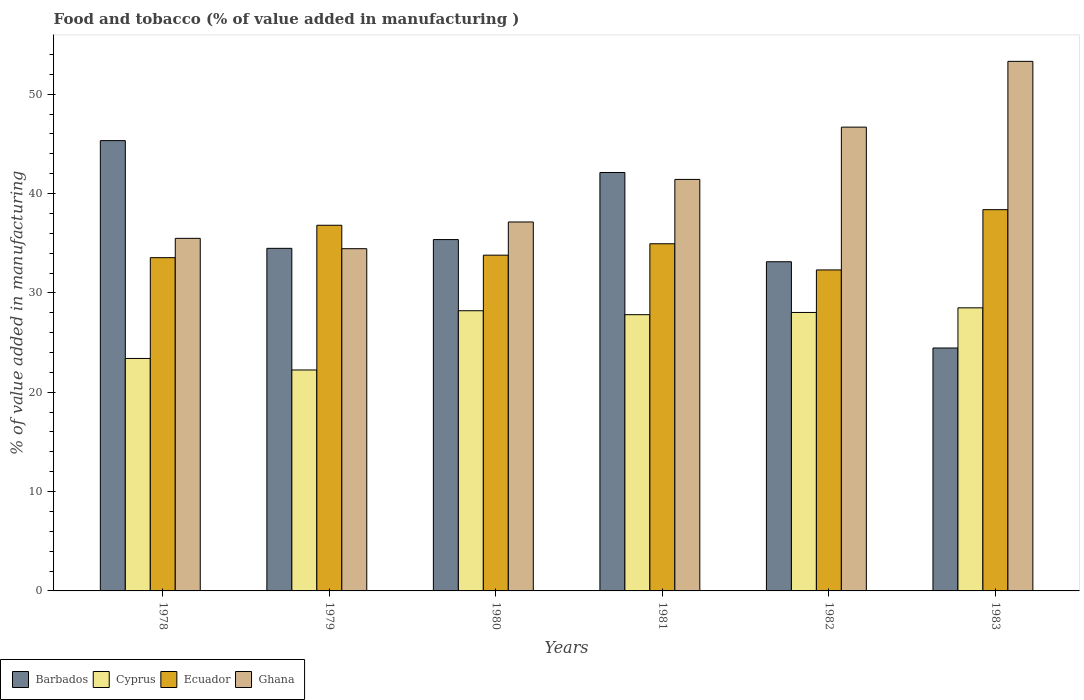How many different coloured bars are there?
Offer a very short reply. 4. Are the number of bars per tick equal to the number of legend labels?
Your answer should be very brief. Yes. Are the number of bars on each tick of the X-axis equal?
Give a very brief answer. Yes. How many bars are there on the 1st tick from the right?
Ensure brevity in your answer.  4. What is the label of the 5th group of bars from the left?
Your answer should be very brief. 1982. In how many cases, is the number of bars for a given year not equal to the number of legend labels?
Your answer should be compact. 0. What is the value added in manufacturing food and tobacco in Barbados in 1981?
Your answer should be compact. 42.12. Across all years, what is the maximum value added in manufacturing food and tobacco in Ecuador?
Make the answer very short. 38.38. Across all years, what is the minimum value added in manufacturing food and tobacco in Ghana?
Provide a succinct answer. 34.45. In which year was the value added in manufacturing food and tobacco in Ghana minimum?
Your answer should be compact. 1979. What is the total value added in manufacturing food and tobacco in Ecuador in the graph?
Make the answer very short. 209.78. What is the difference between the value added in manufacturing food and tobacco in Ghana in 1981 and that in 1983?
Offer a terse response. -11.88. What is the difference between the value added in manufacturing food and tobacco in Ghana in 1981 and the value added in manufacturing food and tobacco in Barbados in 1982?
Offer a very short reply. 8.29. What is the average value added in manufacturing food and tobacco in Ghana per year?
Keep it short and to the point. 41.41. In the year 1980, what is the difference between the value added in manufacturing food and tobacco in Cyprus and value added in manufacturing food and tobacco in Ghana?
Ensure brevity in your answer.  -8.93. In how many years, is the value added in manufacturing food and tobacco in Ghana greater than 16 %?
Ensure brevity in your answer.  6. What is the ratio of the value added in manufacturing food and tobacco in Barbados in 1979 to that in 1983?
Ensure brevity in your answer.  1.41. What is the difference between the highest and the second highest value added in manufacturing food and tobacco in Cyprus?
Ensure brevity in your answer.  0.29. What is the difference between the highest and the lowest value added in manufacturing food and tobacco in Ghana?
Provide a succinct answer. 18.86. Is the sum of the value added in manufacturing food and tobacco in Ecuador in 1979 and 1981 greater than the maximum value added in manufacturing food and tobacco in Cyprus across all years?
Your answer should be compact. Yes. What does the 2nd bar from the left in 1978 represents?
Provide a short and direct response. Cyprus. What does the 4th bar from the right in 1983 represents?
Make the answer very short. Barbados. Is it the case that in every year, the sum of the value added in manufacturing food and tobacco in Ghana and value added in manufacturing food and tobacco in Barbados is greater than the value added in manufacturing food and tobacco in Ecuador?
Offer a very short reply. Yes. Are all the bars in the graph horizontal?
Give a very brief answer. No. What is the difference between two consecutive major ticks on the Y-axis?
Your answer should be compact. 10. Where does the legend appear in the graph?
Provide a short and direct response. Bottom left. What is the title of the graph?
Offer a terse response. Food and tobacco (% of value added in manufacturing ). Does "Andorra" appear as one of the legend labels in the graph?
Your response must be concise. No. What is the label or title of the Y-axis?
Provide a succinct answer. % of value added in manufacturing. What is the % of value added in manufacturing of Barbados in 1978?
Give a very brief answer. 45.33. What is the % of value added in manufacturing in Cyprus in 1978?
Your answer should be compact. 23.4. What is the % of value added in manufacturing in Ecuador in 1978?
Your answer should be very brief. 33.54. What is the % of value added in manufacturing in Ghana in 1978?
Provide a short and direct response. 35.49. What is the % of value added in manufacturing of Barbados in 1979?
Ensure brevity in your answer.  34.48. What is the % of value added in manufacturing in Cyprus in 1979?
Keep it short and to the point. 22.24. What is the % of value added in manufacturing of Ecuador in 1979?
Give a very brief answer. 36.81. What is the % of value added in manufacturing in Ghana in 1979?
Give a very brief answer. 34.45. What is the % of value added in manufacturing of Barbados in 1980?
Keep it short and to the point. 35.37. What is the % of value added in manufacturing in Cyprus in 1980?
Keep it short and to the point. 28.2. What is the % of value added in manufacturing of Ecuador in 1980?
Keep it short and to the point. 33.8. What is the % of value added in manufacturing of Ghana in 1980?
Make the answer very short. 37.14. What is the % of value added in manufacturing in Barbados in 1981?
Your answer should be compact. 42.12. What is the % of value added in manufacturing in Cyprus in 1981?
Make the answer very short. 27.81. What is the % of value added in manufacturing of Ecuador in 1981?
Ensure brevity in your answer.  34.94. What is the % of value added in manufacturing in Ghana in 1981?
Offer a very short reply. 41.42. What is the % of value added in manufacturing in Barbados in 1982?
Offer a terse response. 33.13. What is the % of value added in manufacturing in Cyprus in 1982?
Your answer should be very brief. 28.03. What is the % of value added in manufacturing in Ecuador in 1982?
Offer a terse response. 32.31. What is the % of value added in manufacturing of Ghana in 1982?
Make the answer very short. 46.68. What is the % of value added in manufacturing in Barbados in 1983?
Offer a terse response. 24.45. What is the % of value added in manufacturing in Cyprus in 1983?
Keep it short and to the point. 28.49. What is the % of value added in manufacturing of Ecuador in 1983?
Your answer should be very brief. 38.38. What is the % of value added in manufacturing of Ghana in 1983?
Your answer should be very brief. 53.3. Across all years, what is the maximum % of value added in manufacturing of Barbados?
Offer a terse response. 45.33. Across all years, what is the maximum % of value added in manufacturing in Cyprus?
Ensure brevity in your answer.  28.49. Across all years, what is the maximum % of value added in manufacturing in Ecuador?
Your response must be concise. 38.38. Across all years, what is the maximum % of value added in manufacturing in Ghana?
Offer a terse response. 53.3. Across all years, what is the minimum % of value added in manufacturing in Barbados?
Offer a very short reply. 24.45. Across all years, what is the minimum % of value added in manufacturing of Cyprus?
Keep it short and to the point. 22.24. Across all years, what is the minimum % of value added in manufacturing in Ecuador?
Provide a short and direct response. 32.31. Across all years, what is the minimum % of value added in manufacturing of Ghana?
Offer a very short reply. 34.45. What is the total % of value added in manufacturing in Barbados in the graph?
Make the answer very short. 214.88. What is the total % of value added in manufacturing in Cyprus in the graph?
Offer a very short reply. 158.17. What is the total % of value added in manufacturing of Ecuador in the graph?
Make the answer very short. 209.78. What is the total % of value added in manufacturing in Ghana in the graph?
Make the answer very short. 248.48. What is the difference between the % of value added in manufacturing of Barbados in 1978 and that in 1979?
Offer a terse response. 10.84. What is the difference between the % of value added in manufacturing in Cyprus in 1978 and that in 1979?
Your response must be concise. 1.16. What is the difference between the % of value added in manufacturing in Ecuador in 1978 and that in 1979?
Your answer should be very brief. -3.26. What is the difference between the % of value added in manufacturing in Ghana in 1978 and that in 1979?
Your answer should be compact. 1.04. What is the difference between the % of value added in manufacturing of Barbados in 1978 and that in 1980?
Your answer should be compact. 9.96. What is the difference between the % of value added in manufacturing in Cyprus in 1978 and that in 1980?
Offer a terse response. -4.8. What is the difference between the % of value added in manufacturing of Ecuador in 1978 and that in 1980?
Give a very brief answer. -0.25. What is the difference between the % of value added in manufacturing in Ghana in 1978 and that in 1980?
Provide a short and direct response. -1.65. What is the difference between the % of value added in manufacturing in Barbados in 1978 and that in 1981?
Provide a succinct answer. 3.21. What is the difference between the % of value added in manufacturing of Cyprus in 1978 and that in 1981?
Your answer should be very brief. -4.41. What is the difference between the % of value added in manufacturing in Ecuador in 1978 and that in 1981?
Keep it short and to the point. -1.4. What is the difference between the % of value added in manufacturing of Ghana in 1978 and that in 1981?
Your answer should be very brief. -5.93. What is the difference between the % of value added in manufacturing of Barbados in 1978 and that in 1982?
Your response must be concise. 12.19. What is the difference between the % of value added in manufacturing in Cyprus in 1978 and that in 1982?
Give a very brief answer. -4.63. What is the difference between the % of value added in manufacturing in Ecuador in 1978 and that in 1982?
Give a very brief answer. 1.24. What is the difference between the % of value added in manufacturing in Ghana in 1978 and that in 1982?
Offer a very short reply. -11.19. What is the difference between the % of value added in manufacturing in Barbados in 1978 and that in 1983?
Your answer should be very brief. 20.88. What is the difference between the % of value added in manufacturing of Cyprus in 1978 and that in 1983?
Provide a succinct answer. -5.1. What is the difference between the % of value added in manufacturing in Ecuador in 1978 and that in 1983?
Give a very brief answer. -4.83. What is the difference between the % of value added in manufacturing of Ghana in 1978 and that in 1983?
Ensure brevity in your answer.  -17.81. What is the difference between the % of value added in manufacturing of Barbados in 1979 and that in 1980?
Make the answer very short. -0.88. What is the difference between the % of value added in manufacturing in Cyprus in 1979 and that in 1980?
Your answer should be compact. -5.96. What is the difference between the % of value added in manufacturing of Ecuador in 1979 and that in 1980?
Give a very brief answer. 3.01. What is the difference between the % of value added in manufacturing of Ghana in 1979 and that in 1980?
Your answer should be compact. -2.69. What is the difference between the % of value added in manufacturing in Barbados in 1979 and that in 1981?
Your answer should be very brief. -7.63. What is the difference between the % of value added in manufacturing of Cyprus in 1979 and that in 1981?
Your answer should be compact. -5.57. What is the difference between the % of value added in manufacturing in Ecuador in 1979 and that in 1981?
Your answer should be compact. 1.86. What is the difference between the % of value added in manufacturing in Ghana in 1979 and that in 1981?
Ensure brevity in your answer.  -6.97. What is the difference between the % of value added in manufacturing in Barbados in 1979 and that in 1982?
Provide a succinct answer. 1.35. What is the difference between the % of value added in manufacturing in Cyprus in 1979 and that in 1982?
Your answer should be very brief. -5.79. What is the difference between the % of value added in manufacturing of Ecuador in 1979 and that in 1982?
Make the answer very short. 4.5. What is the difference between the % of value added in manufacturing in Ghana in 1979 and that in 1982?
Offer a terse response. -12.24. What is the difference between the % of value added in manufacturing of Barbados in 1979 and that in 1983?
Keep it short and to the point. 10.03. What is the difference between the % of value added in manufacturing in Cyprus in 1979 and that in 1983?
Make the answer very short. -6.25. What is the difference between the % of value added in manufacturing in Ecuador in 1979 and that in 1983?
Make the answer very short. -1.57. What is the difference between the % of value added in manufacturing in Ghana in 1979 and that in 1983?
Make the answer very short. -18.86. What is the difference between the % of value added in manufacturing of Barbados in 1980 and that in 1981?
Keep it short and to the point. -6.75. What is the difference between the % of value added in manufacturing in Cyprus in 1980 and that in 1981?
Give a very brief answer. 0.4. What is the difference between the % of value added in manufacturing in Ecuador in 1980 and that in 1981?
Your answer should be very brief. -1.15. What is the difference between the % of value added in manufacturing in Ghana in 1980 and that in 1981?
Ensure brevity in your answer.  -4.28. What is the difference between the % of value added in manufacturing in Barbados in 1980 and that in 1982?
Make the answer very short. 2.23. What is the difference between the % of value added in manufacturing of Cyprus in 1980 and that in 1982?
Give a very brief answer. 0.17. What is the difference between the % of value added in manufacturing in Ecuador in 1980 and that in 1982?
Provide a short and direct response. 1.49. What is the difference between the % of value added in manufacturing in Ghana in 1980 and that in 1982?
Give a very brief answer. -9.55. What is the difference between the % of value added in manufacturing in Barbados in 1980 and that in 1983?
Provide a succinct answer. 10.91. What is the difference between the % of value added in manufacturing of Cyprus in 1980 and that in 1983?
Give a very brief answer. -0.29. What is the difference between the % of value added in manufacturing in Ecuador in 1980 and that in 1983?
Offer a very short reply. -4.58. What is the difference between the % of value added in manufacturing in Ghana in 1980 and that in 1983?
Your answer should be very brief. -16.17. What is the difference between the % of value added in manufacturing in Barbados in 1981 and that in 1982?
Provide a short and direct response. 8.98. What is the difference between the % of value added in manufacturing of Cyprus in 1981 and that in 1982?
Your answer should be compact. -0.22. What is the difference between the % of value added in manufacturing of Ecuador in 1981 and that in 1982?
Make the answer very short. 2.64. What is the difference between the % of value added in manufacturing of Ghana in 1981 and that in 1982?
Your answer should be compact. -5.26. What is the difference between the % of value added in manufacturing in Barbados in 1981 and that in 1983?
Offer a terse response. 17.67. What is the difference between the % of value added in manufacturing of Cyprus in 1981 and that in 1983?
Your response must be concise. -0.69. What is the difference between the % of value added in manufacturing in Ecuador in 1981 and that in 1983?
Your response must be concise. -3.43. What is the difference between the % of value added in manufacturing in Ghana in 1981 and that in 1983?
Give a very brief answer. -11.88. What is the difference between the % of value added in manufacturing of Barbados in 1982 and that in 1983?
Your response must be concise. 8.68. What is the difference between the % of value added in manufacturing of Cyprus in 1982 and that in 1983?
Offer a terse response. -0.47. What is the difference between the % of value added in manufacturing of Ecuador in 1982 and that in 1983?
Provide a succinct answer. -6.07. What is the difference between the % of value added in manufacturing of Ghana in 1982 and that in 1983?
Provide a short and direct response. -6.62. What is the difference between the % of value added in manufacturing of Barbados in 1978 and the % of value added in manufacturing of Cyprus in 1979?
Ensure brevity in your answer.  23.09. What is the difference between the % of value added in manufacturing in Barbados in 1978 and the % of value added in manufacturing in Ecuador in 1979?
Keep it short and to the point. 8.52. What is the difference between the % of value added in manufacturing of Barbados in 1978 and the % of value added in manufacturing of Ghana in 1979?
Provide a succinct answer. 10.88. What is the difference between the % of value added in manufacturing in Cyprus in 1978 and the % of value added in manufacturing in Ecuador in 1979?
Your answer should be compact. -13.41. What is the difference between the % of value added in manufacturing of Cyprus in 1978 and the % of value added in manufacturing of Ghana in 1979?
Provide a short and direct response. -11.05. What is the difference between the % of value added in manufacturing in Ecuador in 1978 and the % of value added in manufacturing in Ghana in 1979?
Your response must be concise. -0.9. What is the difference between the % of value added in manufacturing in Barbados in 1978 and the % of value added in manufacturing in Cyprus in 1980?
Keep it short and to the point. 17.12. What is the difference between the % of value added in manufacturing of Barbados in 1978 and the % of value added in manufacturing of Ecuador in 1980?
Your answer should be very brief. 11.53. What is the difference between the % of value added in manufacturing of Barbados in 1978 and the % of value added in manufacturing of Ghana in 1980?
Give a very brief answer. 8.19. What is the difference between the % of value added in manufacturing in Cyprus in 1978 and the % of value added in manufacturing in Ecuador in 1980?
Make the answer very short. -10.4. What is the difference between the % of value added in manufacturing in Cyprus in 1978 and the % of value added in manufacturing in Ghana in 1980?
Your answer should be compact. -13.74. What is the difference between the % of value added in manufacturing of Ecuador in 1978 and the % of value added in manufacturing of Ghana in 1980?
Provide a succinct answer. -3.59. What is the difference between the % of value added in manufacturing in Barbados in 1978 and the % of value added in manufacturing in Cyprus in 1981?
Offer a terse response. 17.52. What is the difference between the % of value added in manufacturing in Barbados in 1978 and the % of value added in manufacturing in Ecuador in 1981?
Offer a terse response. 10.38. What is the difference between the % of value added in manufacturing in Barbados in 1978 and the % of value added in manufacturing in Ghana in 1981?
Provide a short and direct response. 3.91. What is the difference between the % of value added in manufacturing of Cyprus in 1978 and the % of value added in manufacturing of Ecuador in 1981?
Give a very brief answer. -11.55. What is the difference between the % of value added in manufacturing of Cyprus in 1978 and the % of value added in manufacturing of Ghana in 1981?
Make the answer very short. -18.02. What is the difference between the % of value added in manufacturing of Ecuador in 1978 and the % of value added in manufacturing of Ghana in 1981?
Provide a succinct answer. -7.88. What is the difference between the % of value added in manufacturing in Barbados in 1978 and the % of value added in manufacturing in Cyprus in 1982?
Provide a short and direct response. 17.3. What is the difference between the % of value added in manufacturing in Barbados in 1978 and the % of value added in manufacturing in Ecuador in 1982?
Your answer should be compact. 13.02. What is the difference between the % of value added in manufacturing in Barbados in 1978 and the % of value added in manufacturing in Ghana in 1982?
Ensure brevity in your answer.  -1.36. What is the difference between the % of value added in manufacturing in Cyprus in 1978 and the % of value added in manufacturing in Ecuador in 1982?
Keep it short and to the point. -8.91. What is the difference between the % of value added in manufacturing in Cyprus in 1978 and the % of value added in manufacturing in Ghana in 1982?
Offer a terse response. -23.28. What is the difference between the % of value added in manufacturing of Ecuador in 1978 and the % of value added in manufacturing of Ghana in 1982?
Provide a succinct answer. -13.14. What is the difference between the % of value added in manufacturing in Barbados in 1978 and the % of value added in manufacturing in Cyprus in 1983?
Give a very brief answer. 16.83. What is the difference between the % of value added in manufacturing in Barbados in 1978 and the % of value added in manufacturing in Ecuador in 1983?
Provide a short and direct response. 6.95. What is the difference between the % of value added in manufacturing in Barbados in 1978 and the % of value added in manufacturing in Ghana in 1983?
Your response must be concise. -7.98. What is the difference between the % of value added in manufacturing of Cyprus in 1978 and the % of value added in manufacturing of Ecuador in 1983?
Your answer should be very brief. -14.98. What is the difference between the % of value added in manufacturing of Cyprus in 1978 and the % of value added in manufacturing of Ghana in 1983?
Your response must be concise. -29.91. What is the difference between the % of value added in manufacturing of Ecuador in 1978 and the % of value added in manufacturing of Ghana in 1983?
Your response must be concise. -19.76. What is the difference between the % of value added in manufacturing in Barbados in 1979 and the % of value added in manufacturing in Cyprus in 1980?
Give a very brief answer. 6.28. What is the difference between the % of value added in manufacturing in Barbados in 1979 and the % of value added in manufacturing in Ecuador in 1980?
Provide a succinct answer. 0.69. What is the difference between the % of value added in manufacturing in Barbados in 1979 and the % of value added in manufacturing in Ghana in 1980?
Ensure brevity in your answer.  -2.65. What is the difference between the % of value added in manufacturing of Cyprus in 1979 and the % of value added in manufacturing of Ecuador in 1980?
Offer a terse response. -11.56. What is the difference between the % of value added in manufacturing of Cyprus in 1979 and the % of value added in manufacturing of Ghana in 1980?
Offer a terse response. -14.9. What is the difference between the % of value added in manufacturing of Ecuador in 1979 and the % of value added in manufacturing of Ghana in 1980?
Provide a succinct answer. -0.33. What is the difference between the % of value added in manufacturing in Barbados in 1979 and the % of value added in manufacturing in Cyprus in 1981?
Your answer should be compact. 6.68. What is the difference between the % of value added in manufacturing of Barbados in 1979 and the % of value added in manufacturing of Ecuador in 1981?
Provide a succinct answer. -0.46. What is the difference between the % of value added in manufacturing of Barbados in 1979 and the % of value added in manufacturing of Ghana in 1981?
Ensure brevity in your answer.  -6.94. What is the difference between the % of value added in manufacturing in Cyprus in 1979 and the % of value added in manufacturing in Ecuador in 1981?
Keep it short and to the point. -12.71. What is the difference between the % of value added in manufacturing in Cyprus in 1979 and the % of value added in manufacturing in Ghana in 1981?
Make the answer very short. -19.18. What is the difference between the % of value added in manufacturing in Ecuador in 1979 and the % of value added in manufacturing in Ghana in 1981?
Ensure brevity in your answer.  -4.61. What is the difference between the % of value added in manufacturing in Barbados in 1979 and the % of value added in manufacturing in Cyprus in 1982?
Keep it short and to the point. 6.45. What is the difference between the % of value added in manufacturing of Barbados in 1979 and the % of value added in manufacturing of Ecuador in 1982?
Your answer should be very brief. 2.17. What is the difference between the % of value added in manufacturing of Barbados in 1979 and the % of value added in manufacturing of Ghana in 1982?
Make the answer very short. -12.2. What is the difference between the % of value added in manufacturing of Cyprus in 1979 and the % of value added in manufacturing of Ecuador in 1982?
Offer a very short reply. -10.07. What is the difference between the % of value added in manufacturing of Cyprus in 1979 and the % of value added in manufacturing of Ghana in 1982?
Provide a short and direct response. -24.44. What is the difference between the % of value added in manufacturing of Ecuador in 1979 and the % of value added in manufacturing of Ghana in 1982?
Offer a very short reply. -9.88. What is the difference between the % of value added in manufacturing of Barbados in 1979 and the % of value added in manufacturing of Cyprus in 1983?
Provide a short and direct response. 5.99. What is the difference between the % of value added in manufacturing in Barbados in 1979 and the % of value added in manufacturing in Ecuador in 1983?
Ensure brevity in your answer.  -3.89. What is the difference between the % of value added in manufacturing in Barbados in 1979 and the % of value added in manufacturing in Ghana in 1983?
Provide a short and direct response. -18.82. What is the difference between the % of value added in manufacturing in Cyprus in 1979 and the % of value added in manufacturing in Ecuador in 1983?
Offer a terse response. -16.14. What is the difference between the % of value added in manufacturing in Cyprus in 1979 and the % of value added in manufacturing in Ghana in 1983?
Give a very brief answer. -31.06. What is the difference between the % of value added in manufacturing of Ecuador in 1979 and the % of value added in manufacturing of Ghana in 1983?
Provide a short and direct response. -16.5. What is the difference between the % of value added in manufacturing in Barbados in 1980 and the % of value added in manufacturing in Cyprus in 1981?
Make the answer very short. 7.56. What is the difference between the % of value added in manufacturing in Barbados in 1980 and the % of value added in manufacturing in Ecuador in 1981?
Keep it short and to the point. 0.42. What is the difference between the % of value added in manufacturing of Barbados in 1980 and the % of value added in manufacturing of Ghana in 1981?
Offer a terse response. -6.05. What is the difference between the % of value added in manufacturing in Cyprus in 1980 and the % of value added in manufacturing in Ecuador in 1981?
Your answer should be very brief. -6.74. What is the difference between the % of value added in manufacturing of Cyprus in 1980 and the % of value added in manufacturing of Ghana in 1981?
Your answer should be compact. -13.22. What is the difference between the % of value added in manufacturing of Ecuador in 1980 and the % of value added in manufacturing of Ghana in 1981?
Offer a terse response. -7.62. What is the difference between the % of value added in manufacturing in Barbados in 1980 and the % of value added in manufacturing in Cyprus in 1982?
Your response must be concise. 7.34. What is the difference between the % of value added in manufacturing of Barbados in 1980 and the % of value added in manufacturing of Ecuador in 1982?
Your answer should be very brief. 3.06. What is the difference between the % of value added in manufacturing of Barbados in 1980 and the % of value added in manufacturing of Ghana in 1982?
Your answer should be very brief. -11.32. What is the difference between the % of value added in manufacturing of Cyprus in 1980 and the % of value added in manufacturing of Ecuador in 1982?
Offer a terse response. -4.11. What is the difference between the % of value added in manufacturing of Cyprus in 1980 and the % of value added in manufacturing of Ghana in 1982?
Provide a short and direct response. -18.48. What is the difference between the % of value added in manufacturing of Ecuador in 1980 and the % of value added in manufacturing of Ghana in 1982?
Ensure brevity in your answer.  -12.89. What is the difference between the % of value added in manufacturing of Barbados in 1980 and the % of value added in manufacturing of Cyprus in 1983?
Make the answer very short. 6.87. What is the difference between the % of value added in manufacturing in Barbados in 1980 and the % of value added in manufacturing in Ecuador in 1983?
Offer a very short reply. -3.01. What is the difference between the % of value added in manufacturing of Barbados in 1980 and the % of value added in manufacturing of Ghana in 1983?
Your response must be concise. -17.94. What is the difference between the % of value added in manufacturing in Cyprus in 1980 and the % of value added in manufacturing in Ecuador in 1983?
Your answer should be very brief. -10.17. What is the difference between the % of value added in manufacturing of Cyprus in 1980 and the % of value added in manufacturing of Ghana in 1983?
Your answer should be compact. -25.1. What is the difference between the % of value added in manufacturing in Ecuador in 1980 and the % of value added in manufacturing in Ghana in 1983?
Provide a short and direct response. -19.51. What is the difference between the % of value added in manufacturing of Barbados in 1981 and the % of value added in manufacturing of Cyprus in 1982?
Ensure brevity in your answer.  14.09. What is the difference between the % of value added in manufacturing of Barbados in 1981 and the % of value added in manufacturing of Ecuador in 1982?
Your answer should be compact. 9.81. What is the difference between the % of value added in manufacturing of Barbados in 1981 and the % of value added in manufacturing of Ghana in 1982?
Your answer should be compact. -4.57. What is the difference between the % of value added in manufacturing in Cyprus in 1981 and the % of value added in manufacturing in Ecuador in 1982?
Keep it short and to the point. -4.5. What is the difference between the % of value added in manufacturing in Cyprus in 1981 and the % of value added in manufacturing in Ghana in 1982?
Provide a succinct answer. -18.88. What is the difference between the % of value added in manufacturing of Ecuador in 1981 and the % of value added in manufacturing of Ghana in 1982?
Your response must be concise. -11.74. What is the difference between the % of value added in manufacturing in Barbados in 1981 and the % of value added in manufacturing in Cyprus in 1983?
Your answer should be very brief. 13.62. What is the difference between the % of value added in manufacturing of Barbados in 1981 and the % of value added in manufacturing of Ecuador in 1983?
Give a very brief answer. 3.74. What is the difference between the % of value added in manufacturing of Barbados in 1981 and the % of value added in manufacturing of Ghana in 1983?
Make the answer very short. -11.19. What is the difference between the % of value added in manufacturing of Cyprus in 1981 and the % of value added in manufacturing of Ecuador in 1983?
Your answer should be compact. -10.57. What is the difference between the % of value added in manufacturing of Cyprus in 1981 and the % of value added in manufacturing of Ghana in 1983?
Offer a very short reply. -25.5. What is the difference between the % of value added in manufacturing of Ecuador in 1981 and the % of value added in manufacturing of Ghana in 1983?
Provide a short and direct response. -18.36. What is the difference between the % of value added in manufacturing in Barbados in 1982 and the % of value added in manufacturing in Cyprus in 1983?
Ensure brevity in your answer.  4.64. What is the difference between the % of value added in manufacturing of Barbados in 1982 and the % of value added in manufacturing of Ecuador in 1983?
Offer a terse response. -5.24. What is the difference between the % of value added in manufacturing of Barbados in 1982 and the % of value added in manufacturing of Ghana in 1983?
Your answer should be compact. -20.17. What is the difference between the % of value added in manufacturing of Cyprus in 1982 and the % of value added in manufacturing of Ecuador in 1983?
Ensure brevity in your answer.  -10.35. What is the difference between the % of value added in manufacturing of Cyprus in 1982 and the % of value added in manufacturing of Ghana in 1983?
Your response must be concise. -25.28. What is the difference between the % of value added in manufacturing of Ecuador in 1982 and the % of value added in manufacturing of Ghana in 1983?
Make the answer very short. -21. What is the average % of value added in manufacturing of Barbados per year?
Ensure brevity in your answer.  35.81. What is the average % of value added in manufacturing of Cyprus per year?
Offer a terse response. 26.36. What is the average % of value added in manufacturing of Ecuador per year?
Keep it short and to the point. 34.96. What is the average % of value added in manufacturing in Ghana per year?
Make the answer very short. 41.41. In the year 1978, what is the difference between the % of value added in manufacturing of Barbados and % of value added in manufacturing of Cyprus?
Offer a terse response. 21.93. In the year 1978, what is the difference between the % of value added in manufacturing in Barbados and % of value added in manufacturing in Ecuador?
Offer a very short reply. 11.78. In the year 1978, what is the difference between the % of value added in manufacturing of Barbados and % of value added in manufacturing of Ghana?
Provide a succinct answer. 9.84. In the year 1978, what is the difference between the % of value added in manufacturing in Cyprus and % of value added in manufacturing in Ecuador?
Provide a short and direct response. -10.15. In the year 1978, what is the difference between the % of value added in manufacturing of Cyprus and % of value added in manufacturing of Ghana?
Keep it short and to the point. -12.09. In the year 1978, what is the difference between the % of value added in manufacturing in Ecuador and % of value added in manufacturing in Ghana?
Your answer should be compact. -1.95. In the year 1979, what is the difference between the % of value added in manufacturing in Barbados and % of value added in manufacturing in Cyprus?
Give a very brief answer. 12.24. In the year 1979, what is the difference between the % of value added in manufacturing of Barbados and % of value added in manufacturing of Ecuador?
Offer a terse response. -2.32. In the year 1979, what is the difference between the % of value added in manufacturing of Barbados and % of value added in manufacturing of Ghana?
Offer a terse response. 0.04. In the year 1979, what is the difference between the % of value added in manufacturing in Cyprus and % of value added in manufacturing in Ecuador?
Ensure brevity in your answer.  -14.57. In the year 1979, what is the difference between the % of value added in manufacturing in Cyprus and % of value added in manufacturing in Ghana?
Provide a succinct answer. -12.21. In the year 1979, what is the difference between the % of value added in manufacturing of Ecuador and % of value added in manufacturing of Ghana?
Provide a succinct answer. 2.36. In the year 1980, what is the difference between the % of value added in manufacturing of Barbados and % of value added in manufacturing of Cyprus?
Ensure brevity in your answer.  7.16. In the year 1980, what is the difference between the % of value added in manufacturing in Barbados and % of value added in manufacturing in Ecuador?
Provide a succinct answer. 1.57. In the year 1980, what is the difference between the % of value added in manufacturing in Barbados and % of value added in manufacturing in Ghana?
Provide a short and direct response. -1.77. In the year 1980, what is the difference between the % of value added in manufacturing in Cyprus and % of value added in manufacturing in Ecuador?
Ensure brevity in your answer.  -5.59. In the year 1980, what is the difference between the % of value added in manufacturing in Cyprus and % of value added in manufacturing in Ghana?
Give a very brief answer. -8.93. In the year 1980, what is the difference between the % of value added in manufacturing of Ecuador and % of value added in manufacturing of Ghana?
Provide a short and direct response. -3.34. In the year 1981, what is the difference between the % of value added in manufacturing in Barbados and % of value added in manufacturing in Cyprus?
Keep it short and to the point. 14.31. In the year 1981, what is the difference between the % of value added in manufacturing of Barbados and % of value added in manufacturing of Ecuador?
Provide a short and direct response. 7.17. In the year 1981, what is the difference between the % of value added in manufacturing of Barbados and % of value added in manufacturing of Ghana?
Provide a short and direct response. 0.7. In the year 1981, what is the difference between the % of value added in manufacturing in Cyprus and % of value added in manufacturing in Ecuador?
Give a very brief answer. -7.14. In the year 1981, what is the difference between the % of value added in manufacturing of Cyprus and % of value added in manufacturing of Ghana?
Keep it short and to the point. -13.61. In the year 1981, what is the difference between the % of value added in manufacturing of Ecuador and % of value added in manufacturing of Ghana?
Your answer should be very brief. -6.48. In the year 1982, what is the difference between the % of value added in manufacturing in Barbados and % of value added in manufacturing in Cyprus?
Provide a short and direct response. 5.1. In the year 1982, what is the difference between the % of value added in manufacturing in Barbados and % of value added in manufacturing in Ecuador?
Your response must be concise. 0.82. In the year 1982, what is the difference between the % of value added in manufacturing in Barbados and % of value added in manufacturing in Ghana?
Provide a short and direct response. -13.55. In the year 1982, what is the difference between the % of value added in manufacturing of Cyprus and % of value added in manufacturing of Ecuador?
Offer a very short reply. -4.28. In the year 1982, what is the difference between the % of value added in manufacturing of Cyprus and % of value added in manufacturing of Ghana?
Your answer should be very brief. -18.65. In the year 1982, what is the difference between the % of value added in manufacturing of Ecuador and % of value added in manufacturing of Ghana?
Your response must be concise. -14.37. In the year 1983, what is the difference between the % of value added in manufacturing in Barbados and % of value added in manufacturing in Cyprus?
Your answer should be compact. -4.04. In the year 1983, what is the difference between the % of value added in manufacturing in Barbados and % of value added in manufacturing in Ecuador?
Give a very brief answer. -13.93. In the year 1983, what is the difference between the % of value added in manufacturing in Barbados and % of value added in manufacturing in Ghana?
Offer a terse response. -28.85. In the year 1983, what is the difference between the % of value added in manufacturing of Cyprus and % of value added in manufacturing of Ecuador?
Provide a succinct answer. -9.88. In the year 1983, what is the difference between the % of value added in manufacturing of Cyprus and % of value added in manufacturing of Ghana?
Keep it short and to the point. -24.81. In the year 1983, what is the difference between the % of value added in manufacturing of Ecuador and % of value added in manufacturing of Ghana?
Provide a short and direct response. -14.93. What is the ratio of the % of value added in manufacturing of Barbados in 1978 to that in 1979?
Keep it short and to the point. 1.31. What is the ratio of the % of value added in manufacturing of Cyprus in 1978 to that in 1979?
Provide a succinct answer. 1.05. What is the ratio of the % of value added in manufacturing in Ecuador in 1978 to that in 1979?
Offer a very short reply. 0.91. What is the ratio of the % of value added in manufacturing of Ghana in 1978 to that in 1979?
Provide a short and direct response. 1.03. What is the ratio of the % of value added in manufacturing of Barbados in 1978 to that in 1980?
Provide a short and direct response. 1.28. What is the ratio of the % of value added in manufacturing of Cyprus in 1978 to that in 1980?
Keep it short and to the point. 0.83. What is the ratio of the % of value added in manufacturing in Ecuador in 1978 to that in 1980?
Offer a very short reply. 0.99. What is the ratio of the % of value added in manufacturing in Ghana in 1978 to that in 1980?
Provide a succinct answer. 0.96. What is the ratio of the % of value added in manufacturing of Barbados in 1978 to that in 1981?
Give a very brief answer. 1.08. What is the ratio of the % of value added in manufacturing of Cyprus in 1978 to that in 1981?
Provide a short and direct response. 0.84. What is the ratio of the % of value added in manufacturing in Ecuador in 1978 to that in 1981?
Provide a succinct answer. 0.96. What is the ratio of the % of value added in manufacturing in Ghana in 1978 to that in 1981?
Your answer should be very brief. 0.86. What is the ratio of the % of value added in manufacturing in Barbados in 1978 to that in 1982?
Make the answer very short. 1.37. What is the ratio of the % of value added in manufacturing of Cyprus in 1978 to that in 1982?
Give a very brief answer. 0.83. What is the ratio of the % of value added in manufacturing of Ecuador in 1978 to that in 1982?
Keep it short and to the point. 1.04. What is the ratio of the % of value added in manufacturing of Ghana in 1978 to that in 1982?
Your answer should be very brief. 0.76. What is the ratio of the % of value added in manufacturing in Barbados in 1978 to that in 1983?
Your answer should be very brief. 1.85. What is the ratio of the % of value added in manufacturing in Cyprus in 1978 to that in 1983?
Offer a very short reply. 0.82. What is the ratio of the % of value added in manufacturing in Ecuador in 1978 to that in 1983?
Offer a very short reply. 0.87. What is the ratio of the % of value added in manufacturing in Ghana in 1978 to that in 1983?
Provide a short and direct response. 0.67. What is the ratio of the % of value added in manufacturing in Barbados in 1979 to that in 1980?
Give a very brief answer. 0.98. What is the ratio of the % of value added in manufacturing of Cyprus in 1979 to that in 1980?
Your answer should be compact. 0.79. What is the ratio of the % of value added in manufacturing in Ecuador in 1979 to that in 1980?
Keep it short and to the point. 1.09. What is the ratio of the % of value added in manufacturing in Ghana in 1979 to that in 1980?
Make the answer very short. 0.93. What is the ratio of the % of value added in manufacturing of Barbados in 1979 to that in 1981?
Give a very brief answer. 0.82. What is the ratio of the % of value added in manufacturing in Cyprus in 1979 to that in 1981?
Your response must be concise. 0.8. What is the ratio of the % of value added in manufacturing of Ecuador in 1979 to that in 1981?
Offer a very short reply. 1.05. What is the ratio of the % of value added in manufacturing of Ghana in 1979 to that in 1981?
Your answer should be compact. 0.83. What is the ratio of the % of value added in manufacturing of Barbados in 1979 to that in 1982?
Your response must be concise. 1.04. What is the ratio of the % of value added in manufacturing of Cyprus in 1979 to that in 1982?
Keep it short and to the point. 0.79. What is the ratio of the % of value added in manufacturing in Ecuador in 1979 to that in 1982?
Offer a very short reply. 1.14. What is the ratio of the % of value added in manufacturing of Ghana in 1979 to that in 1982?
Provide a succinct answer. 0.74. What is the ratio of the % of value added in manufacturing of Barbados in 1979 to that in 1983?
Offer a terse response. 1.41. What is the ratio of the % of value added in manufacturing of Cyprus in 1979 to that in 1983?
Make the answer very short. 0.78. What is the ratio of the % of value added in manufacturing in Ecuador in 1979 to that in 1983?
Ensure brevity in your answer.  0.96. What is the ratio of the % of value added in manufacturing in Ghana in 1979 to that in 1983?
Make the answer very short. 0.65. What is the ratio of the % of value added in manufacturing in Barbados in 1980 to that in 1981?
Ensure brevity in your answer.  0.84. What is the ratio of the % of value added in manufacturing of Cyprus in 1980 to that in 1981?
Your response must be concise. 1.01. What is the ratio of the % of value added in manufacturing in Ecuador in 1980 to that in 1981?
Offer a very short reply. 0.97. What is the ratio of the % of value added in manufacturing in Ghana in 1980 to that in 1981?
Make the answer very short. 0.9. What is the ratio of the % of value added in manufacturing of Barbados in 1980 to that in 1982?
Your answer should be compact. 1.07. What is the ratio of the % of value added in manufacturing of Cyprus in 1980 to that in 1982?
Provide a short and direct response. 1.01. What is the ratio of the % of value added in manufacturing in Ecuador in 1980 to that in 1982?
Give a very brief answer. 1.05. What is the ratio of the % of value added in manufacturing in Ghana in 1980 to that in 1982?
Provide a succinct answer. 0.8. What is the ratio of the % of value added in manufacturing of Barbados in 1980 to that in 1983?
Offer a very short reply. 1.45. What is the ratio of the % of value added in manufacturing in Ecuador in 1980 to that in 1983?
Your answer should be very brief. 0.88. What is the ratio of the % of value added in manufacturing of Ghana in 1980 to that in 1983?
Ensure brevity in your answer.  0.7. What is the ratio of the % of value added in manufacturing of Barbados in 1981 to that in 1982?
Provide a short and direct response. 1.27. What is the ratio of the % of value added in manufacturing in Ecuador in 1981 to that in 1982?
Provide a succinct answer. 1.08. What is the ratio of the % of value added in manufacturing of Ghana in 1981 to that in 1982?
Provide a short and direct response. 0.89. What is the ratio of the % of value added in manufacturing of Barbados in 1981 to that in 1983?
Your answer should be compact. 1.72. What is the ratio of the % of value added in manufacturing in Cyprus in 1981 to that in 1983?
Keep it short and to the point. 0.98. What is the ratio of the % of value added in manufacturing of Ecuador in 1981 to that in 1983?
Offer a terse response. 0.91. What is the ratio of the % of value added in manufacturing in Ghana in 1981 to that in 1983?
Provide a short and direct response. 0.78. What is the ratio of the % of value added in manufacturing in Barbados in 1982 to that in 1983?
Your response must be concise. 1.36. What is the ratio of the % of value added in manufacturing in Cyprus in 1982 to that in 1983?
Offer a very short reply. 0.98. What is the ratio of the % of value added in manufacturing of Ecuador in 1982 to that in 1983?
Your answer should be very brief. 0.84. What is the ratio of the % of value added in manufacturing of Ghana in 1982 to that in 1983?
Make the answer very short. 0.88. What is the difference between the highest and the second highest % of value added in manufacturing in Barbados?
Your response must be concise. 3.21. What is the difference between the highest and the second highest % of value added in manufacturing in Cyprus?
Provide a succinct answer. 0.29. What is the difference between the highest and the second highest % of value added in manufacturing in Ecuador?
Give a very brief answer. 1.57. What is the difference between the highest and the second highest % of value added in manufacturing of Ghana?
Ensure brevity in your answer.  6.62. What is the difference between the highest and the lowest % of value added in manufacturing in Barbados?
Ensure brevity in your answer.  20.88. What is the difference between the highest and the lowest % of value added in manufacturing in Cyprus?
Ensure brevity in your answer.  6.25. What is the difference between the highest and the lowest % of value added in manufacturing of Ecuador?
Your answer should be very brief. 6.07. What is the difference between the highest and the lowest % of value added in manufacturing of Ghana?
Give a very brief answer. 18.86. 